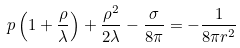<formula> <loc_0><loc_0><loc_500><loc_500>p \left ( 1 + \frac { \rho } { \lambda } \right ) + \frac { \rho ^ { 2 } } { 2 \lambda } - \frac { \sigma } { 8 \pi } = - \frac { 1 } { 8 \pi r ^ { 2 } }</formula> 